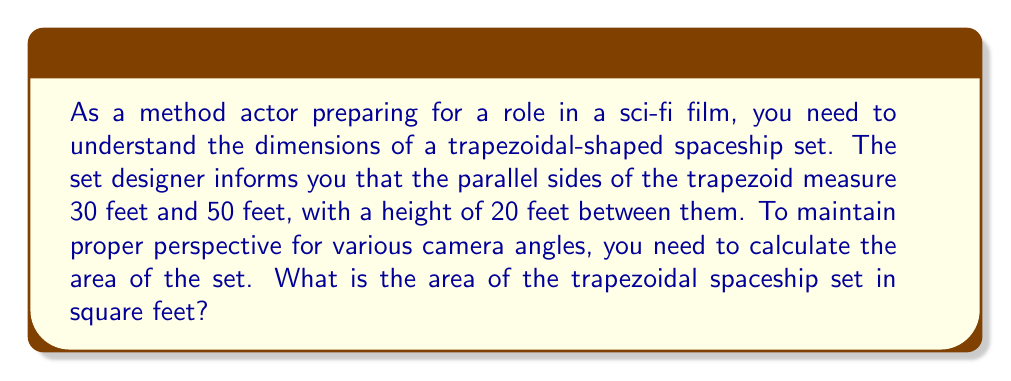Give your solution to this math problem. Let's approach this step-by-step:

1) The formula for the area of a trapezoid is:

   $$A = \frac{1}{2}(b_1 + b_2)h$$

   Where:
   $A$ = area
   $b_1$ and $b_2$ = lengths of the parallel sides
   $h$ = height (distance between the parallel sides)

2) We're given:
   $b_1 = 30$ feet
   $b_2 = 50$ feet
   $h = 20$ feet

3) Let's substitute these values into our formula:

   $$A = \frac{1}{2}(30 + 50) \times 20$$

4) First, add the parallel sides:
   
   $$A = \frac{1}{2}(80) \times 20$$

5) Multiply:
   
   $$A = 40 \times 20$$

6) Calculate the final result:
   
   $$A = 800$$

Therefore, the area of the trapezoidal spaceship set is 800 square feet.
Answer: 800 sq ft 